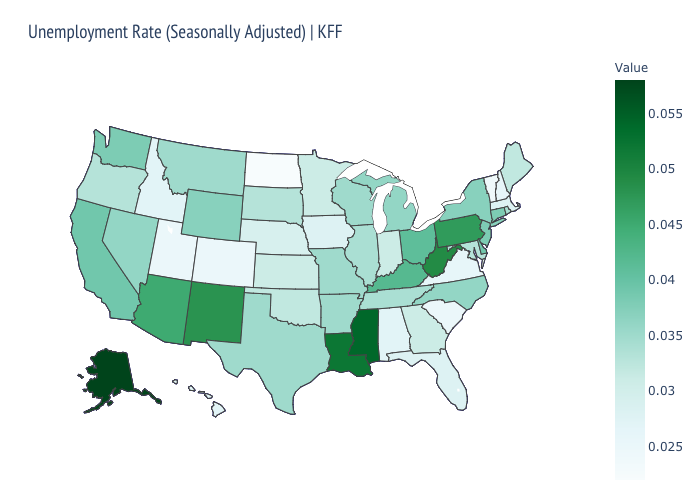Does Alaska have the highest value in the USA?
Give a very brief answer. Yes. Does New Jersey have a lower value than New Mexico?
Short answer required. Yes. Does the map have missing data?
Be succinct. No. 